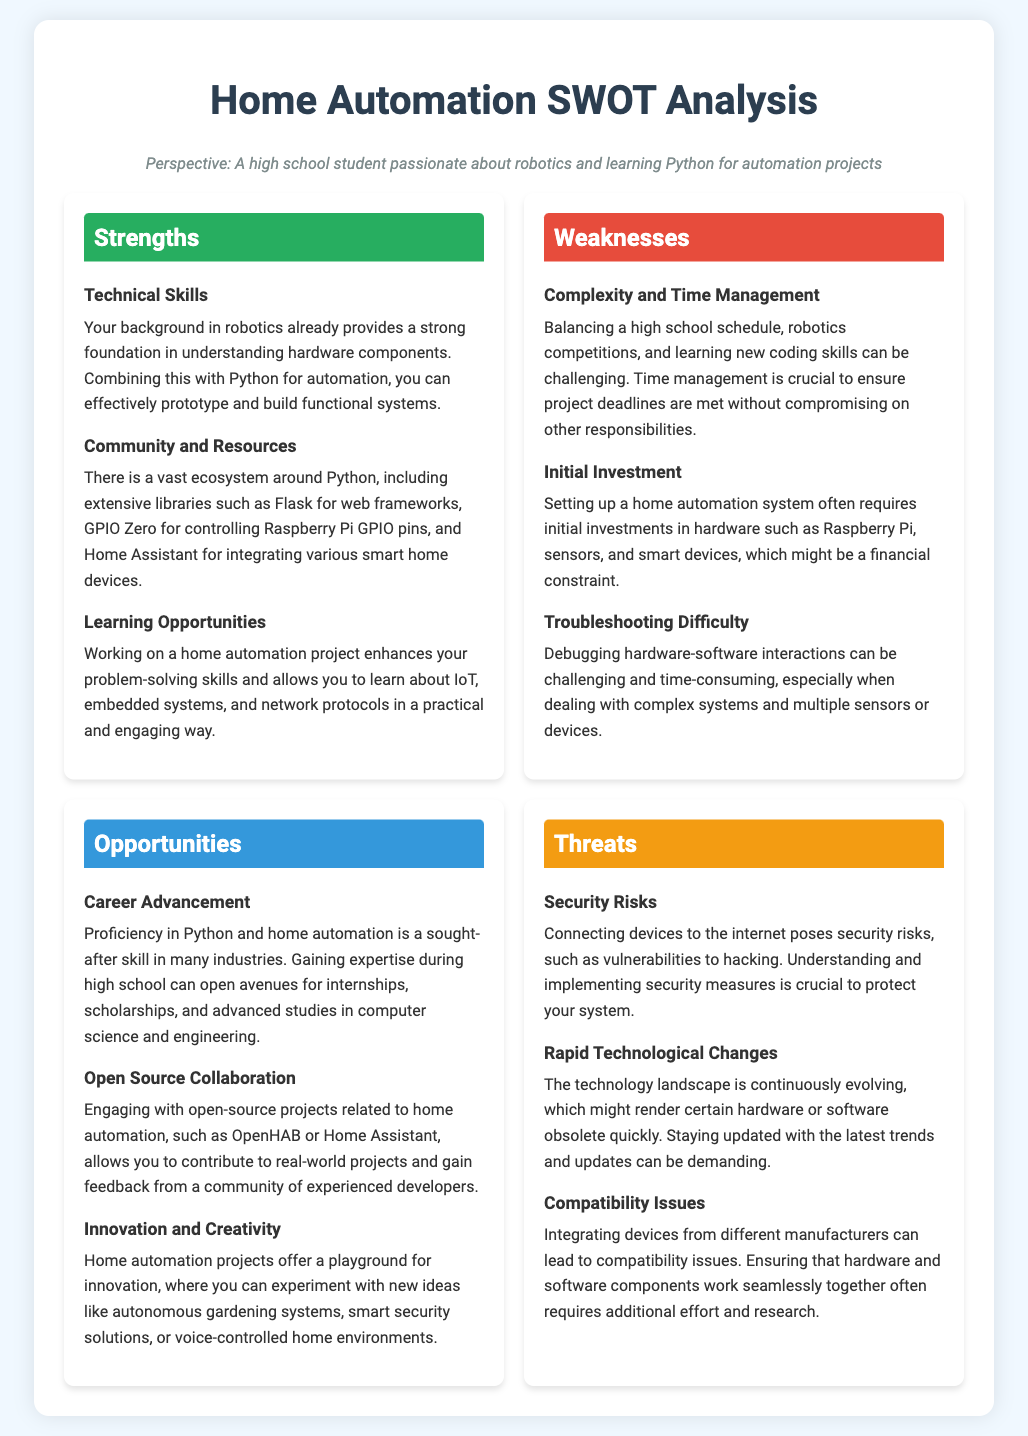What are the strengths listed in the document? The strengths include technical skills, community and resources, and learning opportunities.
Answer: technical skills, community and resources, learning opportunities What are the weaknesses mentioned? The weaknesses consist of complexity and time management, initial investment, and troubleshooting difficulty.
Answer: complexity and time management, initial investment, troubleshooting difficulty How many opportunities are identified? The document lists three opportunities: career advancement, open source collaboration, and innovation and creativity.
Answer: three What is a possible career benefit mentioned? Proficiency in Python and home automation can lead to internships, scholarships, and advanced studies.
Answer: internships, scholarships, advanced studies What is one major security risk in home automation? The document highlights vulnerabilities to hacking as a significant security risk.
Answer: vulnerabilities to hacking What type of projects could allow for open-source collaboration? Engaging with open-source projects like OpenHAB or Home Assistant allows for collaboration.
Answer: OpenHAB, Home Assistant What is a challenge related to troubleshooting? Debugging hardware-software interactions can be challenging and time-consuming.
Answer: challenging and time-consuming What is one threat related to technology change? Rapid technological changes might render certain hardware or software obsolete quickly.
Answer: obsolete quickly 